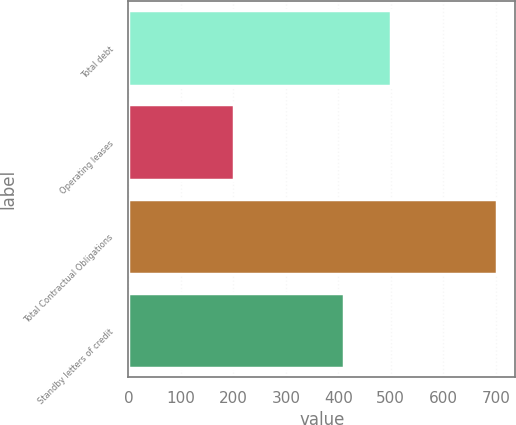Convert chart. <chart><loc_0><loc_0><loc_500><loc_500><bar_chart><fcel>Total debt<fcel>Operating leases<fcel>Total Contractual Obligations<fcel>Standby letters of credit<nl><fcel>500<fcel>202<fcel>702<fcel>411<nl></chart> 